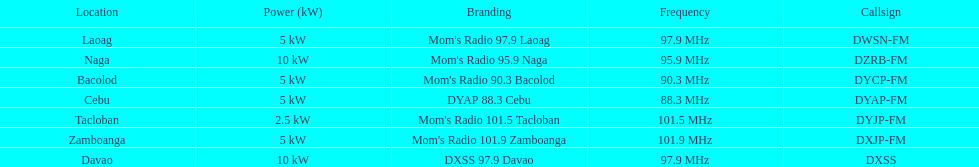Which of these stations emits with the least power? Mom's Radio 101.5 Tacloban. 